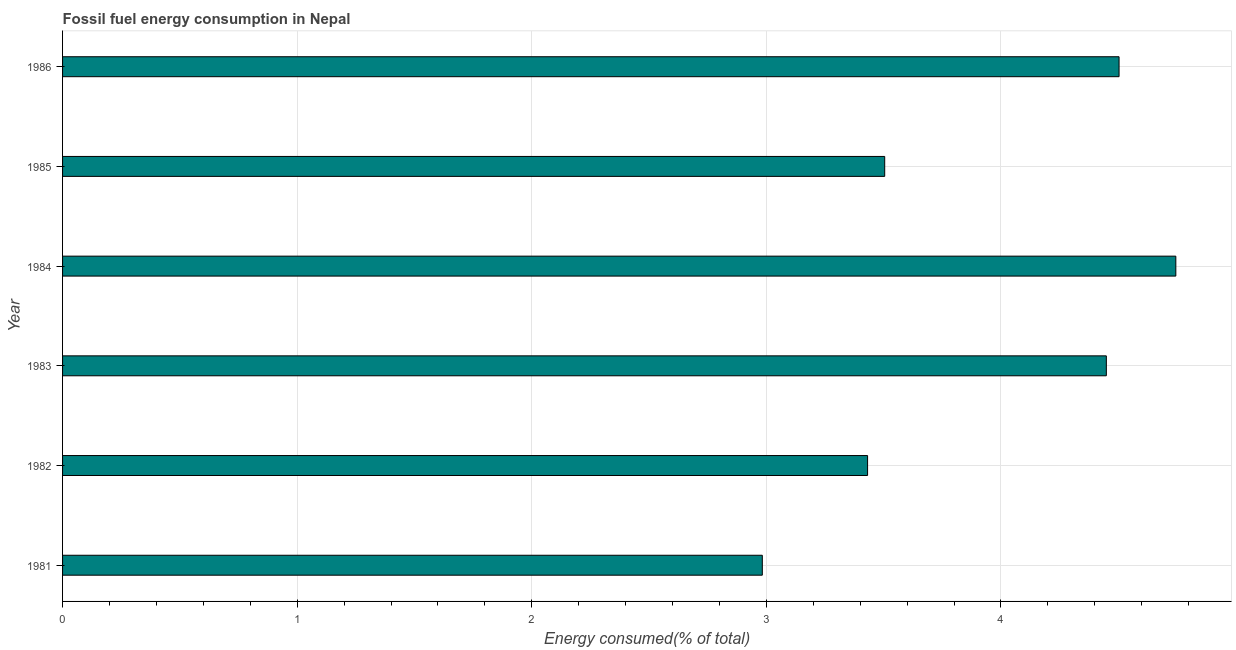What is the title of the graph?
Your response must be concise. Fossil fuel energy consumption in Nepal. What is the label or title of the X-axis?
Offer a very short reply. Energy consumed(% of total). What is the fossil fuel energy consumption in 1982?
Your answer should be very brief. 3.43. Across all years, what is the maximum fossil fuel energy consumption?
Give a very brief answer. 4.75. Across all years, what is the minimum fossil fuel energy consumption?
Your response must be concise. 2.98. What is the sum of the fossil fuel energy consumption?
Your response must be concise. 23.62. What is the difference between the fossil fuel energy consumption in 1983 and 1984?
Offer a very short reply. -0.3. What is the average fossil fuel energy consumption per year?
Keep it short and to the point. 3.94. What is the median fossil fuel energy consumption?
Provide a succinct answer. 3.98. What is the ratio of the fossil fuel energy consumption in 1985 to that in 1986?
Your answer should be compact. 0.78. Is the fossil fuel energy consumption in 1981 less than that in 1986?
Ensure brevity in your answer.  Yes. What is the difference between the highest and the second highest fossil fuel energy consumption?
Give a very brief answer. 0.24. Is the sum of the fossil fuel energy consumption in 1982 and 1983 greater than the maximum fossil fuel energy consumption across all years?
Ensure brevity in your answer.  Yes. What is the difference between the highest and the lowest fossil fuel energy consumption?
Your answer should be compact. 1.76. How many years are there in the graph?
Make the answer very short. 6. What is the difference between two consecutive major ticks on the X-axis?
Make the answer very short. 1. What is the Energy consumed(% of total) of 1981?
Ensure brevity in your answer.  2.98. What is the Energy consumed(% of total) in 1982?
Your response must be concise. 3.43. What is the Energy consumed(% of total) in 1983?
Provide a succinct answer. 4.45. What is the Energy consumed(% of total) in 1984?
Your response must be concise. 4.75. What is the Energy consumed(% of total) of 1985?
Keep it short and to the point. 3.5. What is the Energy consumed(% of total) of 1986?
Keep it short and to the point. 4.5. What is the difference between the Energy consumed(% of total) in 1981 and 1982?
Your response must be concise. -0.45. What is the difference between the Energy consumed(% of total) in 1981 and 1983?
Make the answer very short. -1.47. What is the difference between the Energy consumed(% of total) in 1981 and 1984?
Give a very brief answer. -1.76. What is the difference between the Energy consumed(% of total) in 1981 and 1985?
Give a very brief answer. -0.52. What is the difference between the Energy consumed(% of total) in 1981 and 1986?
Keep it short and to the point. -1.52. What is the difference between the Energy consumed(% of total) in 1982 and 1983?
Your answer should be very brief. -1.02. What is the difference between the Energy consumed(% of total) in 1982 and 1984?
Offer a very short reply. -1.31. What is the difference between the Energy consumed(% of total) in 1982 and 1985?
Keep it short and to the point. -0.07. What is the difference between the Energy consumed(% of total) in 1982 and 1986?
Provide a succinct answer. -1.07. What is the difference between the Energy consumed(% of total) in 1983 and 1984?
Make the answer very short. -0.3. What is the difference between the Energy consumed(% of total) in 1983 and 1985?
Keep it short and to the point. 0.94. What is the difference between the Energy consumed(% of total) in 1983 and 1986?
Your answer should be compact. -0.05. What is the difference between the Energy consumed(% of total) in 1984 and 1985?
Make the answer very short. 1.24. What is the difference between the Energy consumed(% of total) in 1984 and 1986?
Make the answer very short. 0.24. What is the difference between the Energy consumed(% of total) in 1985 and 1986?
Make the answer very short. -1. What is the ratio of the Energy consumed(% of total) in 1981 to that in 1982?
Ensure brevity in your answer.  0.87. What is the ratio of the Energy consumed(% of total) in 1981 to that in 1983?
Your response must be concise. 0.67. What is the ratio of the Energy consumed(% of total) in 1981 to that in 1984?
Your answer should be very brief. 0.63. What is the ratio of the Energy consumed(% of total) in 1981 to that in 1985?
Make the answer very short. 0.85. What is the ratio of the Energy consumed(% of total) in 1981 to that in 1986?
Your response must be concise. 0.66. What is the ratio of the Energy consumed(% of total) in 1982 to that in 1983?
Your response must be concise. 0.77. What is the ratio of the Energy consumed(% of total) in 1982 to that in 1984?
Provide a succinct answer. 0.72. What is the ratio of the Energy consumed(% of total) in 1982 to that in 1986?
Make the answer very short. 0.76. What is the ratio of the Energy consumed(% of total) in 1983 to that in 1984?
Give a very brief answer. 0.94. What is the ratio of the Energy consumed(% of total) in 1983 to that in 1985?
Your answer should be very brief. 1.27. What is the ratio of the Energy consumed(% of total) in 1984 to that in 1985?
Your answer should be very brief. 1.35. What is the ratio of the Energy consumed(% of total) in 1984 to that in 1986?
Keep it short and to the point. 1.05. What is the ratio of the Energy consumed(% of total) in 1985 to that in 1986?
Offer a terse response. 0.78. 